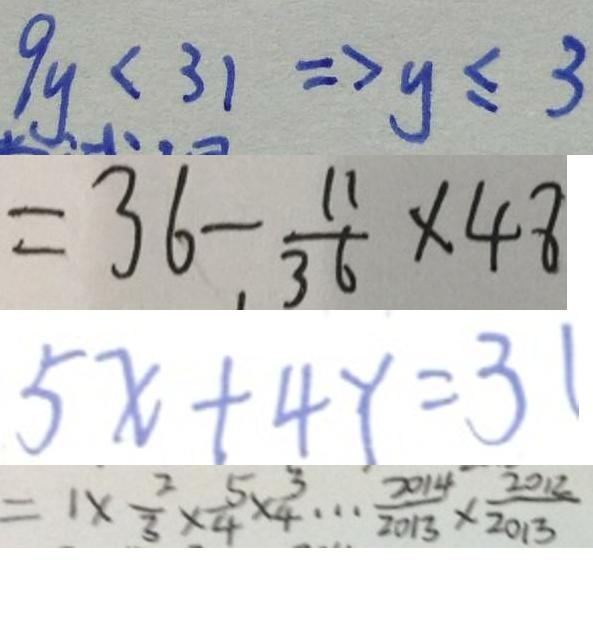<formula> <loc_0><loc_0><loc_500><loc_500>9 y < 3 1 \Rightarrow y \leq 3 
 = 3 6 - \frac { 1 1 } { 3 6 } \times 4 8 
 5 x + 4 Y = 3 1 
 = 1 \times \frac { 2 } { 3 } \times \frac { 5 } { 4 } \times \frac { 3 } { 4 } \cdots \frac { 2 0 1 4 } { 2 0 1 3 } \times \frac { 2 0 1 2 } { 2 0 1 3 }</formula> 